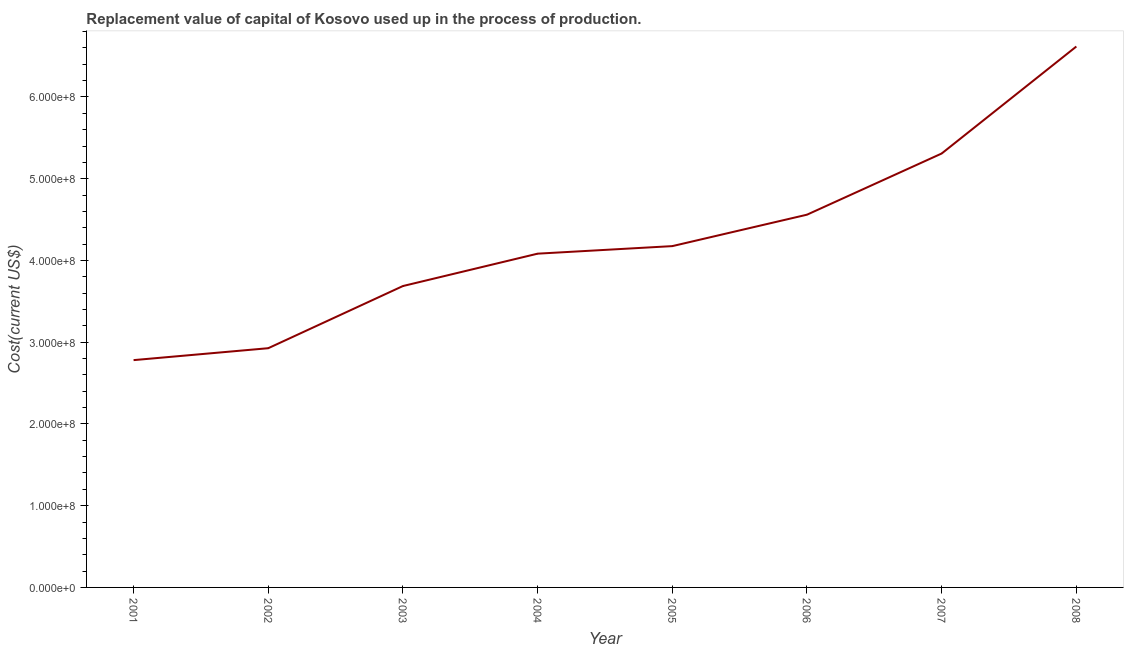What is the consumption of fixed capital in 2003?
Your answer should be compact. 3.69e+08. Across all years, what is the maximum consumption of fixed capital?
Keep it short and to the point. 6.62e+08. Across all years, what is the minimum consumption of fixed capital?
Your response must be concise. 2.78e+08. In which year was the consumption of fixed capital maximum?
Provide a succinct answer. 2008. What is the sum of the consumption of fixed capital?
Provide a succinct answer. 3.41e+09. What is the difference between the consumption of fixed capital in 2005 and 2007?
Provide a short and direct response. -1.13e+08. What is the average consumption of fixed capital per year?
Keep it short and to the point. 4.27e+08. What is the median consumption of fixed capital?
Keep it short and to the point. 4.13e+08. In how many years, is the consumption of fixed capital greater than 260000000 US$?
Make the answer very short. 8. Do a majority of the years between 2001 and 2007 (inclusive) have consumption of fixed capital greater than 220000000 US$?
Provide a succinct answer. Yes. What is the ratio of the consumption of fixed capital in 2002 to that in 2006?
Provide a short and direct response. 0.64. Is the consumption of fixed capital in 2005 less than that in 2007?
Give a very brief answer. Yes. What is the difference between the highest and the second highest consumption of fixed capital?
Give a very brief answer. 1.31e+08. Is the sum of the consumption of fixed capital in 2006 and 2007 greater than the maximum consumption of fixed capital across all years?
Ensure brevity in your answer.  Yes. What is the difference between the highest and the lowest consumption of fixed capital?
Provide a short and direct response. 3.84e+08. How many years are there in the graph?
Make the answer very short. 8. What is the difference between two consecutive major ticks on the Y-axis?
Offer a terse response. 1.00e+08. Are the values on the major ticks of Y-axis written in scientific E-notation?
Provide a short and direct response. Yes. Does the graph contain any zero values?
Give a very brief answer. No. What is the title of the graph?
Your response must be concise. Replacement value of capital of Kosovo used up in the process of production. What is the label or title of the X-axis?
Ensure brevity in your answer.  Year. What is the label or title of the Y-axis?
Ensure brevity in your answer.  Cost(current US$). What is the Cost(current US$) in 2001?
Provide a succinct answer. 2.78e+08. What is the Cost(current US$) in 2002?
Give a very brief answer. 2.93e+08. What is the Cost(current US$) in 2003?
Offer a very short reply. 3.69e+08. What is the Cost(current US$) of 2004?
Your answer should be compact. 4.08e+08. What is the Cost(current US$) of 2005?
Provide a succinct answer. 4.18e+08. What is the Cost(current US$) of 2006?
Provide a succinct answer. 4.56e+08. What is the Cost(current US$) of 2007?
Provide a short and direct response. 5.31e+08. What is the Cost(current US$) of 2008?
Provide a short and direct response. 6.62e+08. What is the difference between the Cost(current US$) in 2001 and 2002?
Your response must be concise. -1.46e+07. What is the difference between the Cost(current US$) in 2001 and 2003?
Your response must be concise. -9.06e+07. What is the difference between the Cost(current US$) in 2001 and 2004?
Offer a terse response. -1.30e+08. What is the difference between the Cost(current US$) in 2001 and 2005?
Keep it short and to the point. -1.39e+08. What is the difference between the Cost(current US$) in 2001 and 2006?
Offer a very short reply. -1.78e+08. What is the difference between the Cost(current US$) in 2001 and 2007?
Provide a short and direct response. -2.53e+08. What is the difference between the Cost(current US$) in 2001 and 2008?
Make the answer very short. -3.84e+08. What is the difference between the Cost(current US$) in 2002 and 2003?
Provide a short and direct response. -7.61e+07. What is the difference between the Cost(current US$) in 2002 and 2004?
Your answer should be very brief. -1.16e+08. What is the difference between the Cost(current US$) in 2002 and 2005?
Provide a short and direct response. -1.25e+08. What is the difference between the Cost(current US$) in 2002 and 2006?
Your response must be concise. -1.63e+08. What is the difference between the Cost(current US$) in 2002 and 2007?
Offer a very short reply. -2.38e+08. What is the difference between the Cost(current US$) in 2002 and 2008?
Your response must be concise. -3.69e+08. What is the difference between the Cost(current US$) in 2003 and 2004?
Provide a short and direct response. -3.96e+07. What is the difference between the Cost(current US$) in 2003 and 2005?
Ensure brevity in your answer.  -4.88e+07. What is the difference between the Cost(current US$) in 2003 and 2006?
Provide a succinct answer. -8.73e+07. What is the difference between the Cost(current US$) in 2003 and 2007?
Your answer should be very brief. -1.62e+08. What is the difference between the Cost(current US$) in 2003 and 2008?
Your answer should be compact. -2.93e+08. What is the difference between the Cost(current US$) in 2004 and 2005?
Your response must be concise. -9.23e+06. What is the difference between the Cost(current US$) in 2004 and 2006?
Give a very brief answer. -4.77e+07. What is the difference between the Cost(current US$) in 2004 and 2007?
Make the answer very short. -1.23e+08. What is the difference between the Cost(current US$) in 2004 and 2008?
Provide a short and direct response. -2.53e+08. What is the difference between the Cost(current US$) in 2005 and 2006?
Offer a terse response. -3.85e+07. What is the difference between the Cost(current US$) in 2005 and 2007?
Offer a very short reply. -1.13e+08. What is the difference between the Cost(current US$) in 2005 and 2008?
Ensure brevity in your answer.  -2.44e+08. What is the difference between the Cost(current US$) in 2006 and 2007?
Your response must be concise. -7.48e+07. What is the difference between the Cost(current US$) in 2006 and 2008?
Your response must be concise. -2.06e+08. What is the difference between the Cost(current US$) in 2007 and 2008?
Offer a terse response. -1.31e+08. What is the ratio of the Cost(current US$) in 2001 to that in 2003?
Offer a terse response. 0.75. What is the ratio of the Cost(current US$) in 2001 to that in 2004?
Offer a very short reply. 0.68. What is the ratio of the Cost(current US$) in 2001 to that in 2005?
Your answer should be compact. 0.67. What is the ratio of the Cost(current US$) in 2001 to that in 2006?
Ensure brevity in your answer.  0.61. What is the ratio of the Cost(current US$) in 2001 to that in 2007?
Ensure brevity in your answer.  0.52. What is the ratio of the Cost(current US$) in 2001 to that in 2008?
Offer a terse response. 0.42. What is the ratio of the Cost(current US$) in 2002 to that in 2003?
Your answer should be very brief. 0.79. What is the ratio of the Cost(current US$) in 2002 to that in 2004?
Provide a short and direct response. 0.72. What is the ratio of the Cost(current US$) in 2002 to that in 2005?
Give a very brief answer. 0.7. What is the ratio of the Cost(current US$) in 2002 to that in 2006?
Ensure brevity in your answer.  0.64. What is the ratio of the Cost(current US$) in 2002 to that in 2007?
Provide a succinct answer. 0.55. What is the ratio of the Cost(current US$) in 2002 to that in 2008?
Ensure brevity in your answer.  0.44. What is the ratio of the Cost(current US$) in 2003 to that in 2004?
Offer a terse response. 0.9. What is the ratio of the Cost(current US$) in 2003 to that in 2005?
Your answer should be very brief. 0.88. What is the ratio of the Cost(current US$) in 2003 to that in 2006?
Give a very brief answer. 0.81. What is the ratio of the Cost(current US$) in 2003 to that in 2007?
Your response must be concise. 0.69. What is the ratio of the Cost(current US$) in 2003 to that in 2008?
Offer a terse response. 0.56. What is the ratio of the Cost(current US$) in 2004 to that in 2005?
Keep it short and to the point. 0.98. What is the ratio of the Cost(current US$) in 2004 to that in 2006?
Your answer should be very brief. 0.9. What is the ratio of the Cost(current US$) in 2004 to that in 2007?
Your response must be concise. 0.77. What is the ratio of the Cost(current US$) in 2004 to that in 2008?
Your response must be concise. 0.62. What is the ratio of the Cost(current US$) in 2005 to that in 2006?
Provide a short and direct response. 0.92. What is the ratio of the Cost(current US$) in 2005 to that in 2007?
Offer a very short reply. 0.79. What is the ratio of the Cost(current US$) in 2005 to that in 2008?
Keep it short and to the point. 0.63. What is the ratio of the Cost(current US$) in 2006 to that in 2007?
Make the answer very short. 0.86. What is the ratio of the Cost(current US$) in 2006 to that in 2008?
Your answer should be very brief. 0.69. What is the ratio of the Cost(current US$) in 2007 to that in 2008?
Your answer should be very brief. 0.8. 